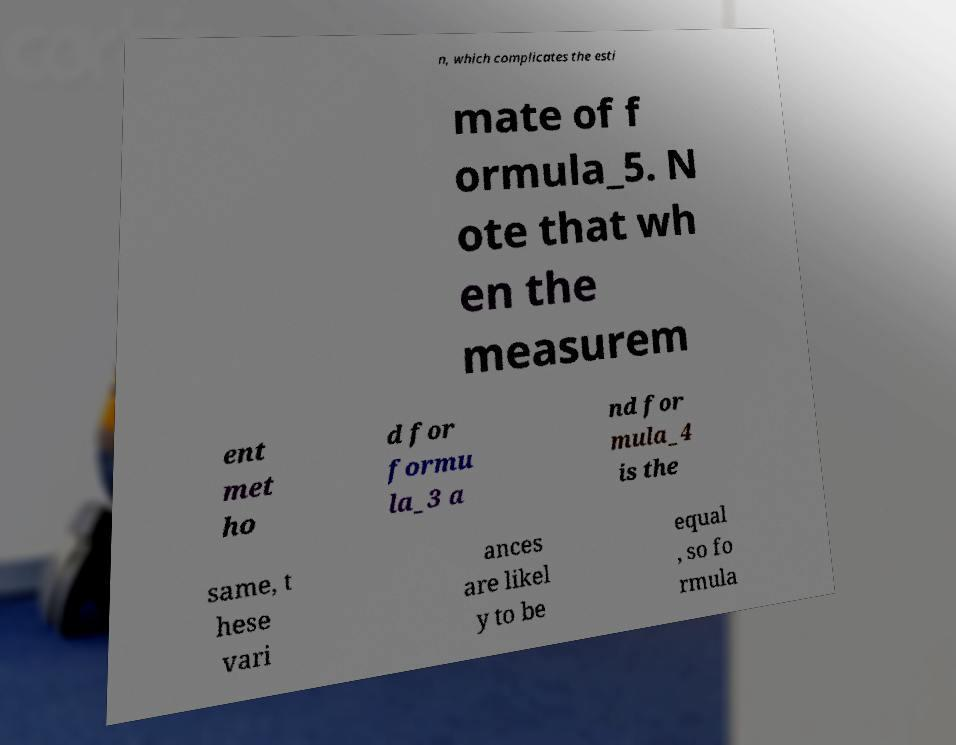What messages or text are displayed in this image? I need them in a readable, typed format. n, which complicates the esti mate of f ormula_5. N ote that wh en the measurem ent met ho d for formu la_3 a nd for mula_4 is the same, t hese vari ances are likel y to be equal , so fo rmula 